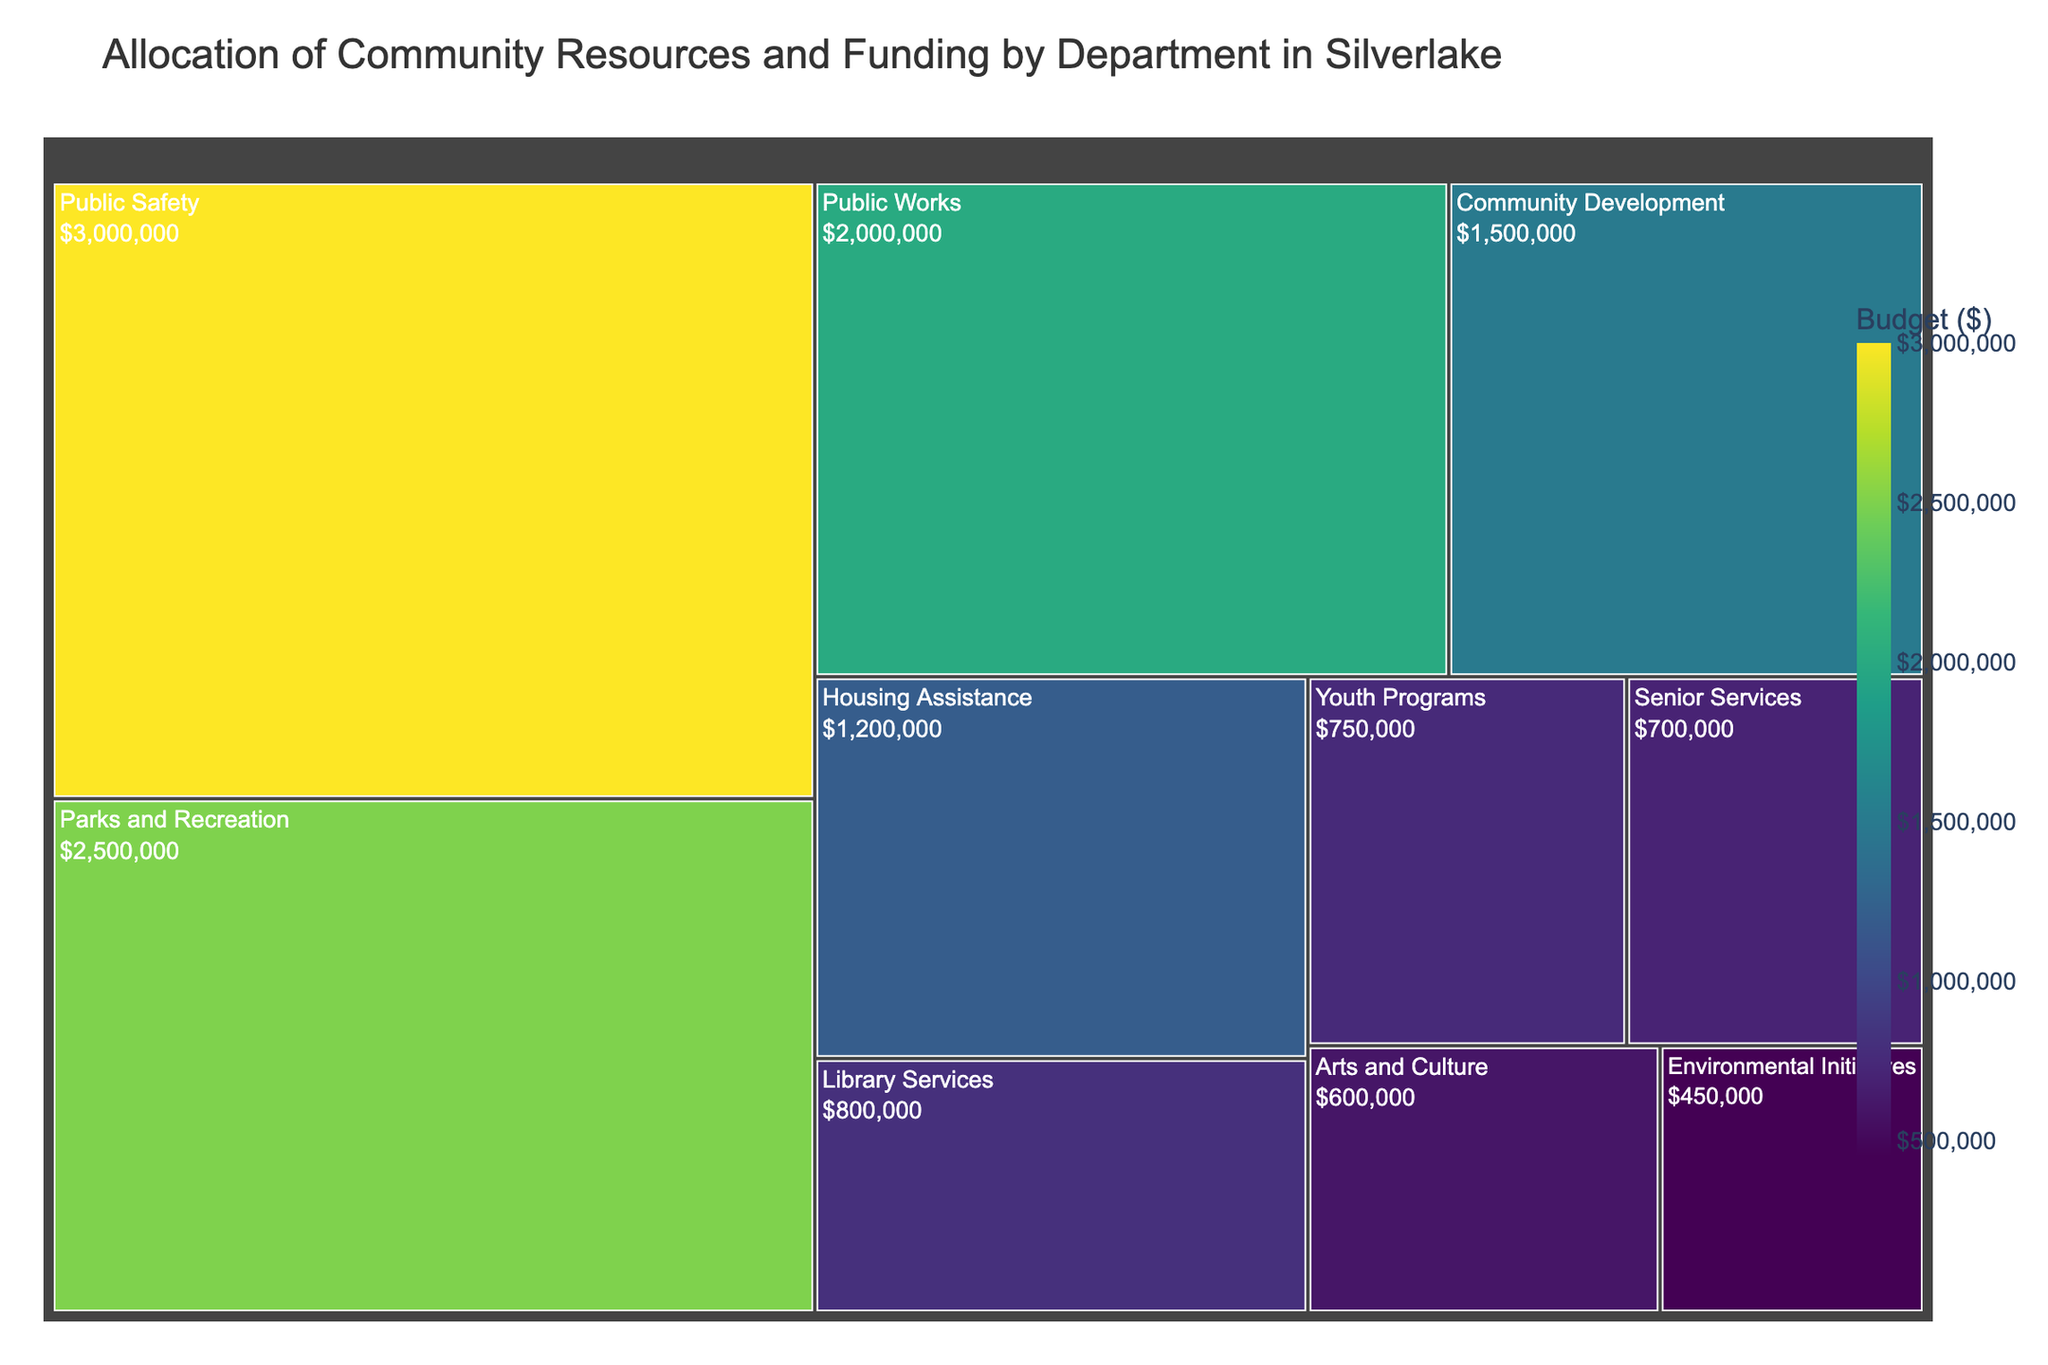What's the title of the treemap? The title is typically displayed at the top of the treemap. In this case, it reads "Allocation of Community Resources and Funding by Department in Silverlake".
Answer: Allocation of Community Resources and Funding by Department in Silverlake What department has the highest budget allocation? The department with the largest area in the treemap represents the highest budget. "Public Safety" occupies the largest space.
Answer: Public Safety Which departments have a budget allocation below $1 million? By examining the sections of the treemap, the departments with budgets under $1 million are "Library Services," "Arts and Culture," "Youth Programs," "Senior Services," and "Environmental Initiatives".
Answer: Library Services, Arts and Culture, Youth Programs, Senior Services, Environmental Initiatives How much larger is the budget for Public Safety compared to Arts and Culture? The Public Safety budget is $3,000,000 and Arts and Culture is $600,000. Subtract the smaller budget from the larger one: $3,000,000 - $600,000 = $2,400,000.
Answer: $2,400,000 What is the combined budget for Parks and Recreation and Community Development? Add the budgets of Parks and Recreation ($2,500,000) and Community Development ($1,500,000): $2,500,000 + $1,500,000 = $4,000,000.
Answer: $4,000,000 Which department has the smallest budget allocation? The department that occupies the smallest area on the treemap is "Environmental Initiatives".
Answer: Environmental Initiatives How does the budget for Housing Assistance compare to Youth Programs? Housing Assistance has a budget of $1,200,000, while Youth Programs has $750,000. Comparing the two, Housing Assistance has a larger budget.
Answer: Housing Assistance What is the average budget allocation across all departments? Sum all the budgets: $2,500,000 (Parks and Recreation) + $2,000,000 (Public Works) + $1,500,000 (Community Development) + $3,000,000 (Public Safety) + $800,000 (Library Services) + $600,000 (Arts and Culture) + $750,000 (Youth Programs) + $700,000 (Senior Services) + $450,000 (Environmental Initiatives) + $1,200,000 (Housing Assistance) = $13,500,000. Divide this by the number of departments: $13,500,000 / 10 = $1,350,000.
Answer: $1,350,000 What percentage of the total budget is allocated to Public Works? Total budget is $13,500,000. The budget for Public Works is $2,000,000. The percentage is calculated as ($2,000,000 / $13,500,000) * 100 ≈ 14.81%.
Answer: 14.81% If you were to redistribute $1,000,000 evenly across all departments, how much additional budget would each department receive? Redistributing $1,000,000 evenly across 10 departments divides to $1,000,000 / 10 = $100,000 per department.
Answer: $100,000 per department 